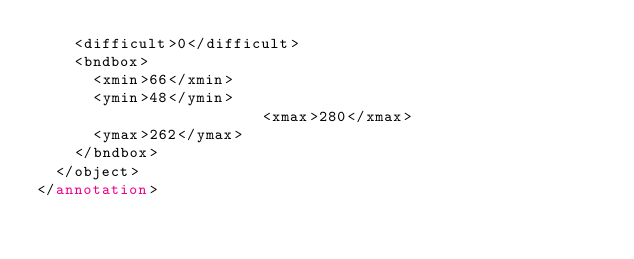<code> <loc_0><loc_0><loc_500><loc_500><_XML_>		<difficult>0</difficult>
		<bndbox>
			<xmin>66</xmin>
			<ymin>48</ymin>
                        <xmax>280</xmax>
			<ymax>262</ymax>
		</bndbox>
	</object>
</annotation>
</code> 